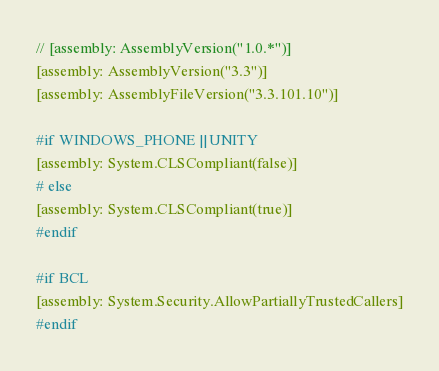<code> <loc_0><loc_0><loc_500><loc_500><_C#_>// [assembly: AssemblyVersion("1.0.*")]
[assembly: AssemblyVersion("3.3")]
[assembly: AssemblyFileVersion("3.3.101.10")]

#if WINDOWS_PHONE || UNITY
[assembly: System.CLSCompliant(false)]
# else
[assembly: System.CLSCompliant(true)]
#endif

#if BCL
[assembly: System.Security.AllowPartiallyTrustedCallers]
#endif</code> 